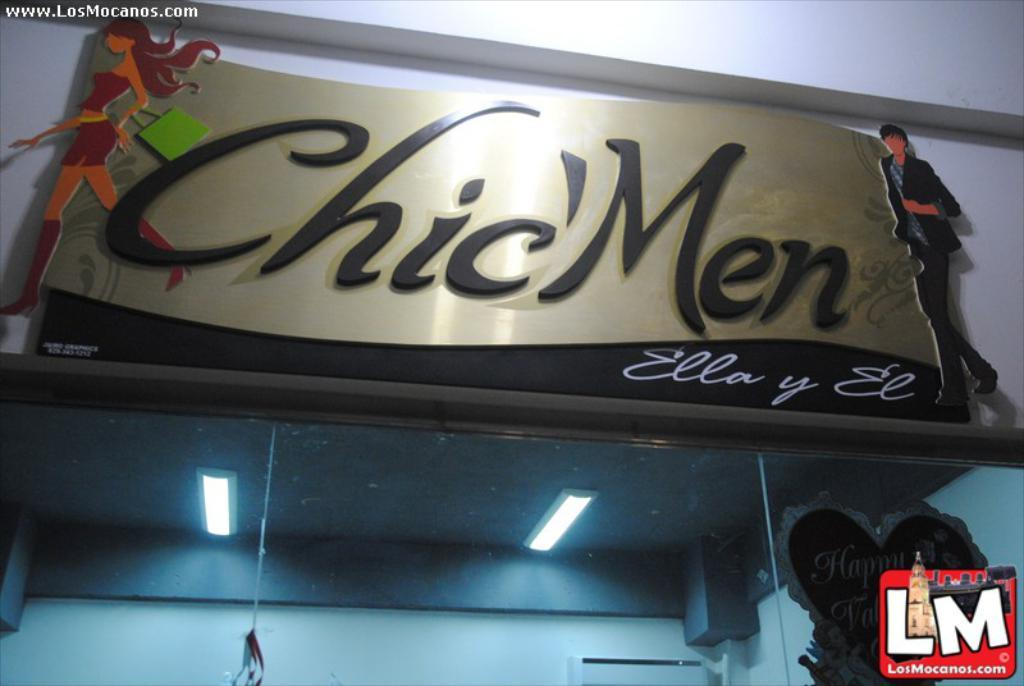What can be identified as the main subject of the image? The name of a store is visible in the image. What is located below the store's name? There are glasses below the store's name. Where was the image taken from? The image was taken from a website. What type of cloth is used to cover the store's windows in the image? There is no cloth visible in the image, nor is there any indication of the store's windows being covered. 